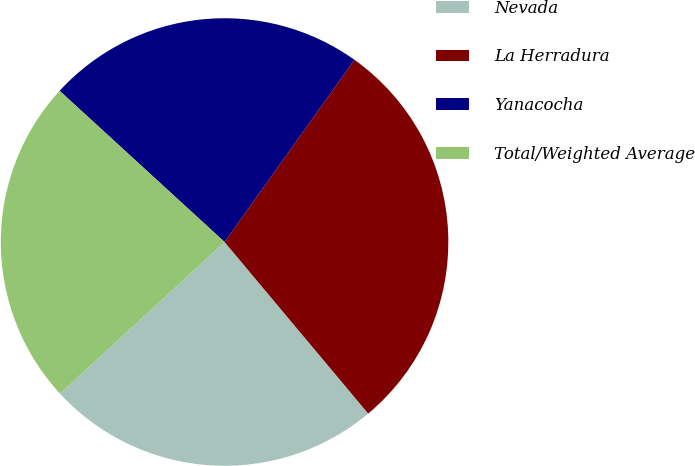<chart> <loc_0><loc_0><loc_500><loc_500><pie_chart><fcel>Nevada<fcel>La Herradura<fcel>Yanacocha<fcel>Total/Weighted Average<nl><fcel>24.25%<fcel>29.05%<fcel>23.05%<fcel>23.65%<nl></chart> 